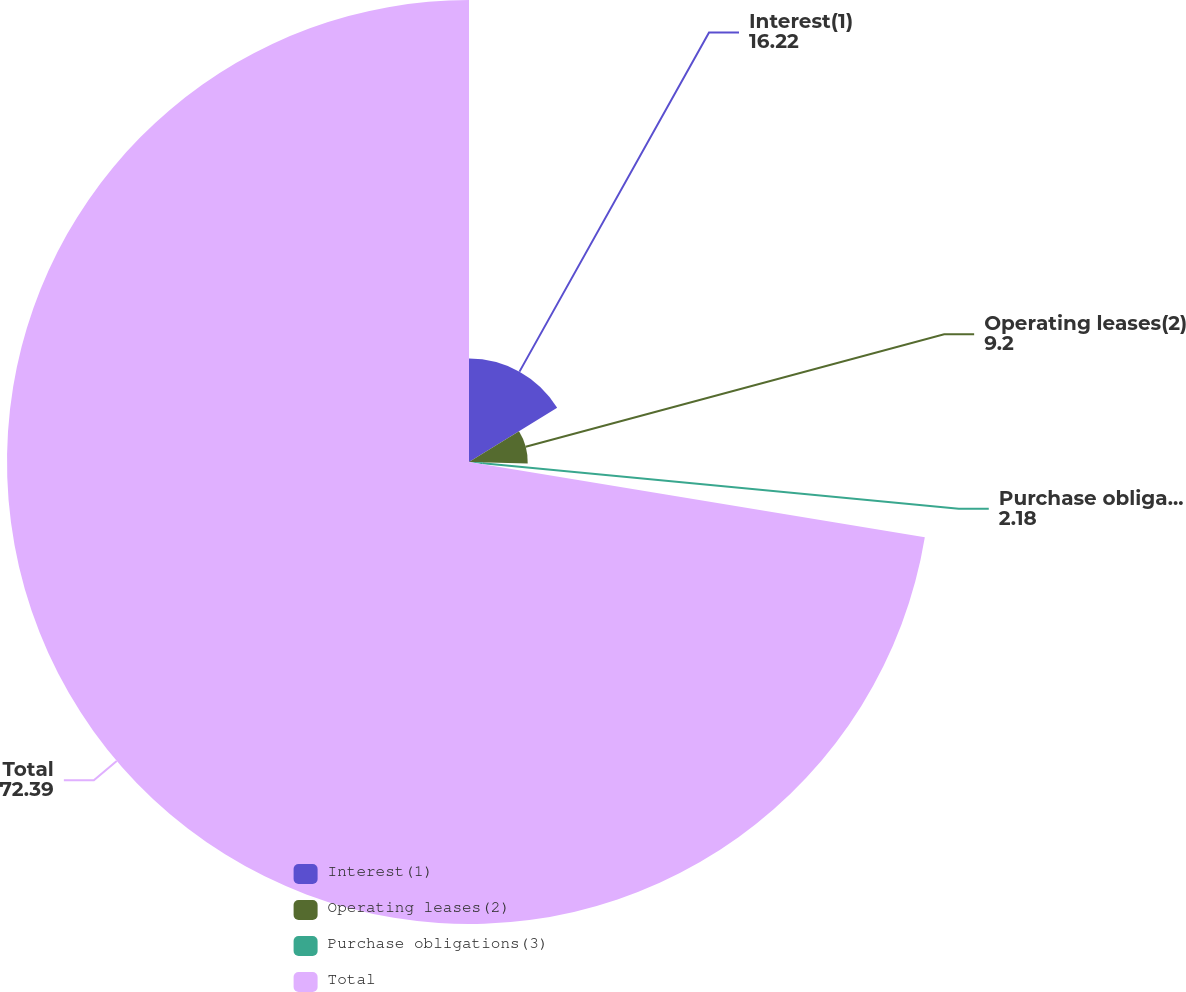<chart> <loc_0><loc_0><loc_500><loc_500><pie_chart><fcel>Interest(1)<fcel>Operating leases(2)<fcel>Purchase obligations(3)<fcel>Total<nl><fcel>16.22%<fcel>9.2%<fcel>2.18%<fcel>72.39%<nl></chart> 